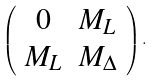<formula> <loc_0><loc_0><loc_500><loc_500>\left ( \begin{array} { c c } 0 & M _ { L } \\ M _ { L } & M _ { \Delta } \end{array} \right ) .</formula> 